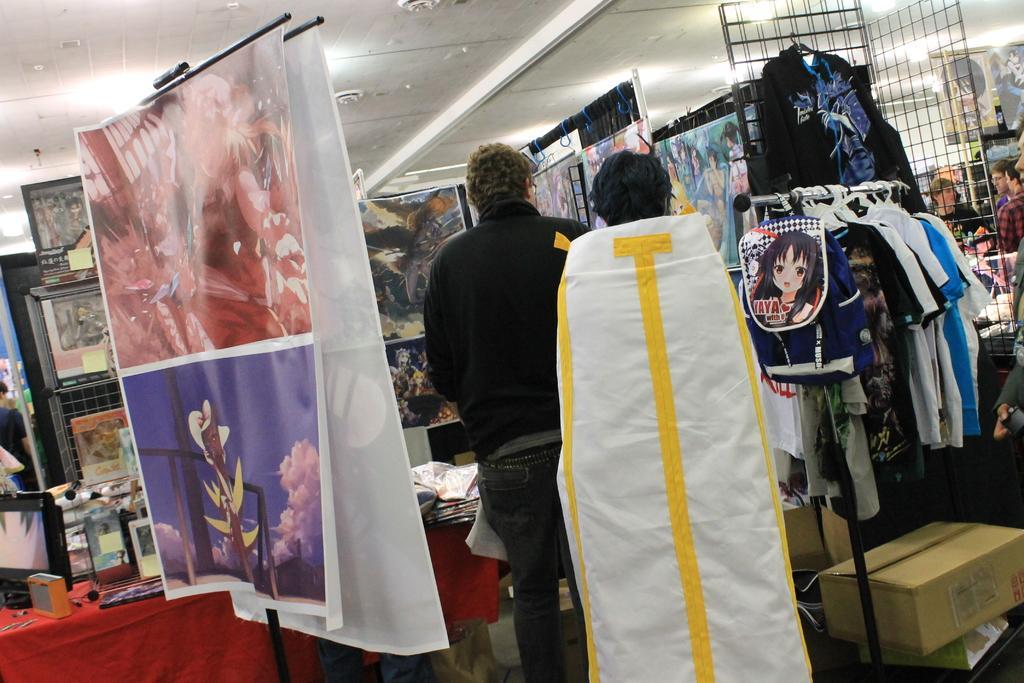Please provide a concise description of this image. In the foreground of this image, there are two persons standing, banners, bag and few clothes hanging to the pole and many objects on the table. In the background, there are posters, ceiling, lights, metal mesh, persons standing and the cardboard boxes on the ground. 